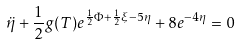Convert formula to latex. <formula><loc_0><loc_0><loc_500><loc_500>\ddot { \eta } + \frac { 1 } { 2 } g ( T ) e ^ { \frac { 1 } { 2 } \Phi + \frac { 1 } { 2 } \xi - 5 \eta } + 8 e ^ { - 4 \eta } = 0</formula> 